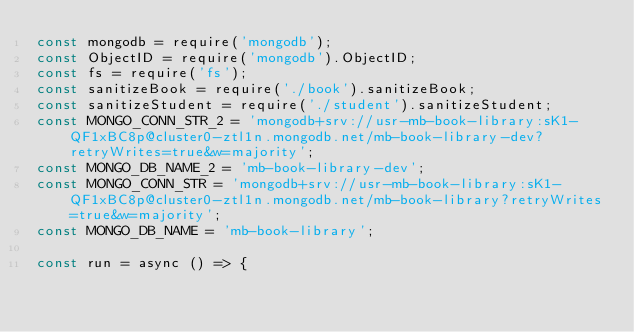Convert code to text. <code><loc_0><loc_0><loc_500><loc_500><_JavaScript_>const mongodb = require('mongodb');
const ObjectID = require('mongodb').ObjectID;
const fs = require('fs');
const sanitizeBook = require('./book').sanitizeBook;
const sanitizeStudent = require('./student').sanitizeStudent;
const MONGO_CONN_STR_2 = 'mongodb+srv://usr-mb-book-library:sK1-QF1xBC8p@cluster0-ztl1n.mongodb.net/mb-book-library-dev?retryWrites=true&w=majority';
const MONGO_DB_NAME_2 = 'mb-book-library-dev';
const MONGO_CONN_STR = 'mongodb+srv://usr-mb-book-library:sK1-QF1xBC8p@cluster0-ztl1n.mongodb.net/mb-book-library?retryWrites=true&w=majority';
const MONGO_DB_NAME = 'mb-book-library';

const run = async () => {</code> 